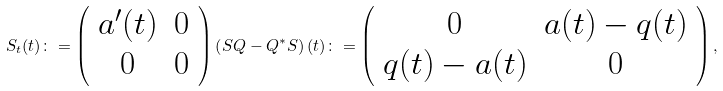<formula> <loc_0><loc_0><loc_500><loc_500>S _ { t } ( t ) \colon = \left ( \begin{array} { c c } a ^ { \prime } ( t ) & 0 \\ 0 & 0 \end{array} \right ) \left ( S Q - Q ^ { * } S \right ) ( t ) \colon = \left ( \begin{array} { c c } 0 & a ( t ) - q ( t ) \\ q ( t ) - a ( t ) & 0 \end{array} \right ) ,</formula> 